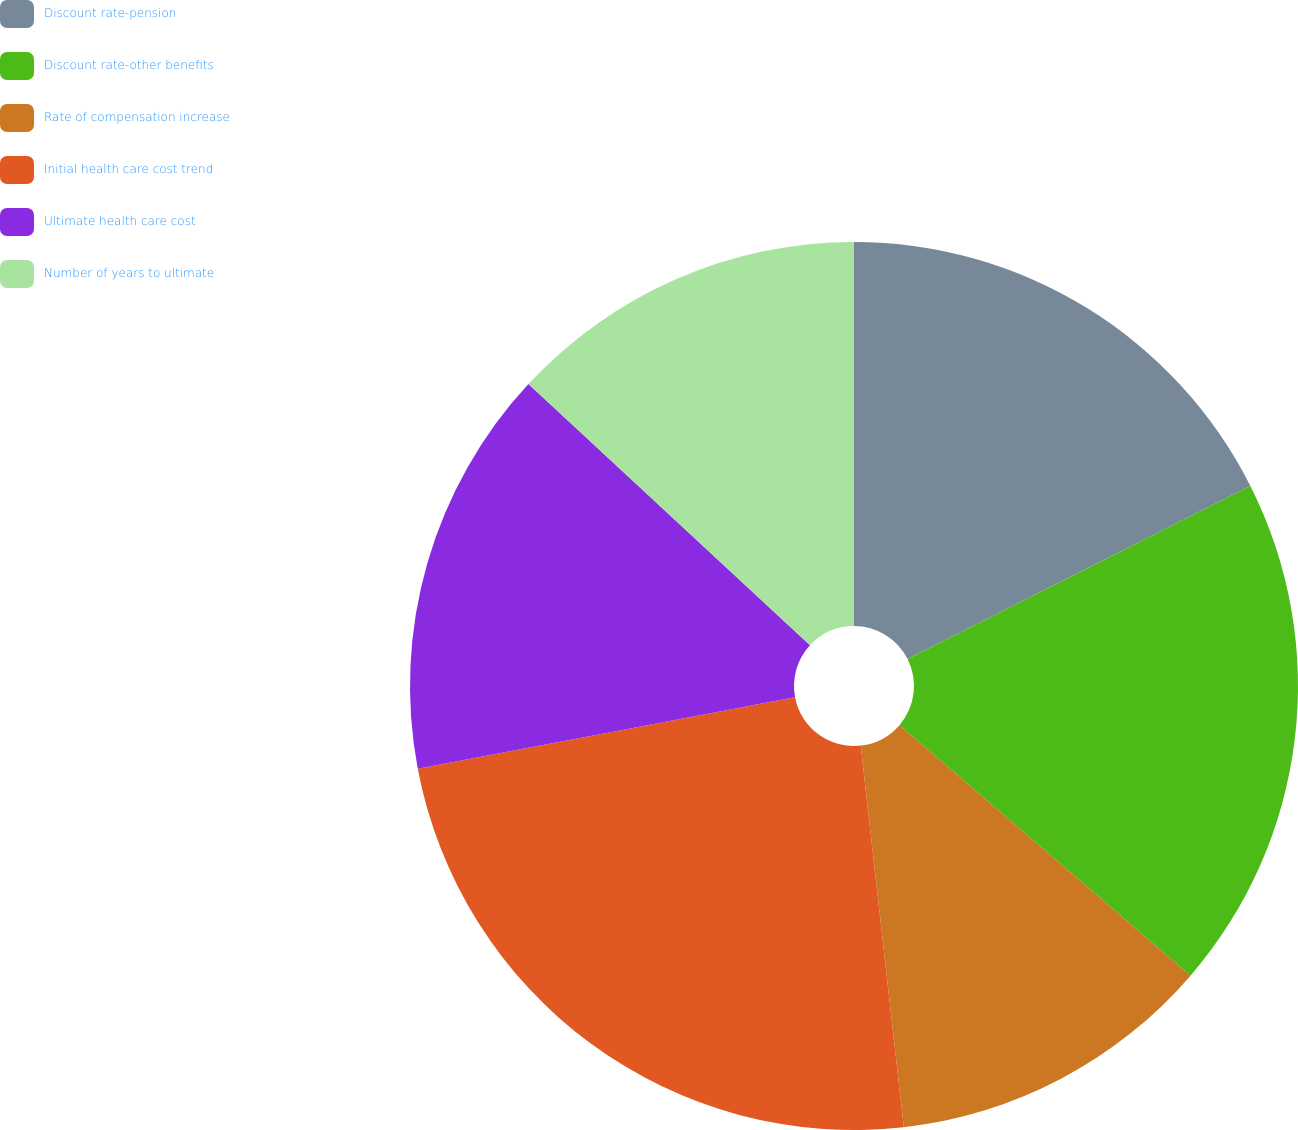<chart> <loc_0><loc_0><loc_500><loc_500><pie_chart><fcel>Discount rate-pension<fcel>Discount rate-other benefits<fcel>Rate of compensation increase<fcel>Initial health care cost trend<fcel>Ultimate health care cost<fcel>Number of years to ultimate<nl><fcel>17.56%<fcel>18.75%<fcel>11.9%<fcel>23.81%<fcel>14.88%<fcel>13.1%<nl></chart> 